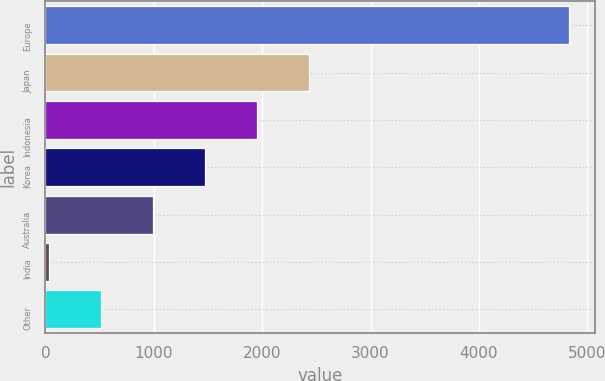Convert chart. <chart><loc_0><loc_0><loc_500><loc_500><bar_chart><fcel>Europe<fcel>Japan<fcel>Indonesia<fcel>Korea<fcel>Australia<fcel>India<fcel>Other<nl><fcel>4831<fcel>2431.5<fcel>1951.6<fcel>1471.7<fcel>991.8<fcel>32<fcel>511.9<nl></chart> 